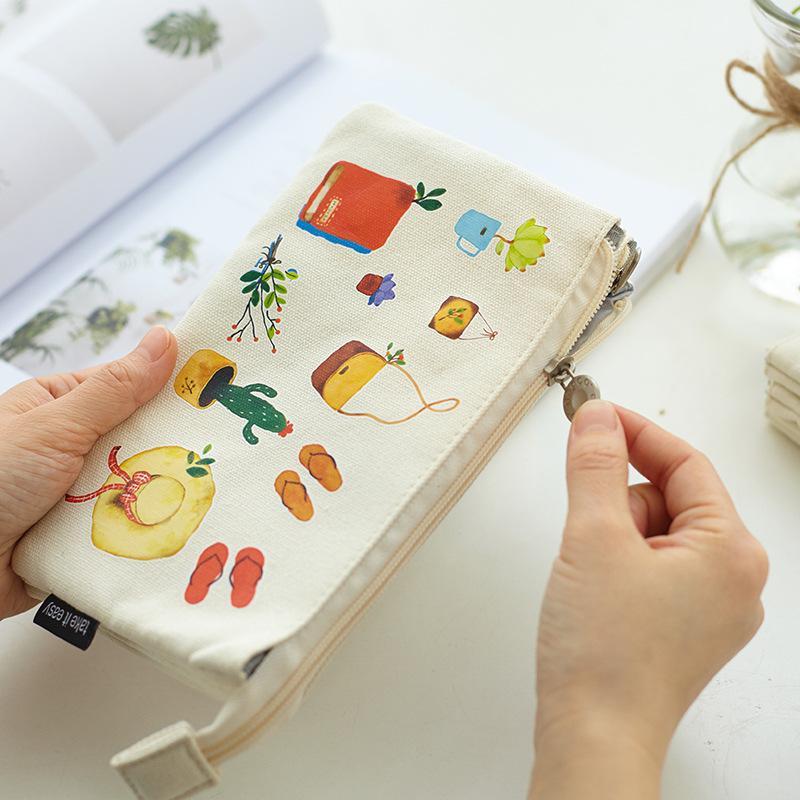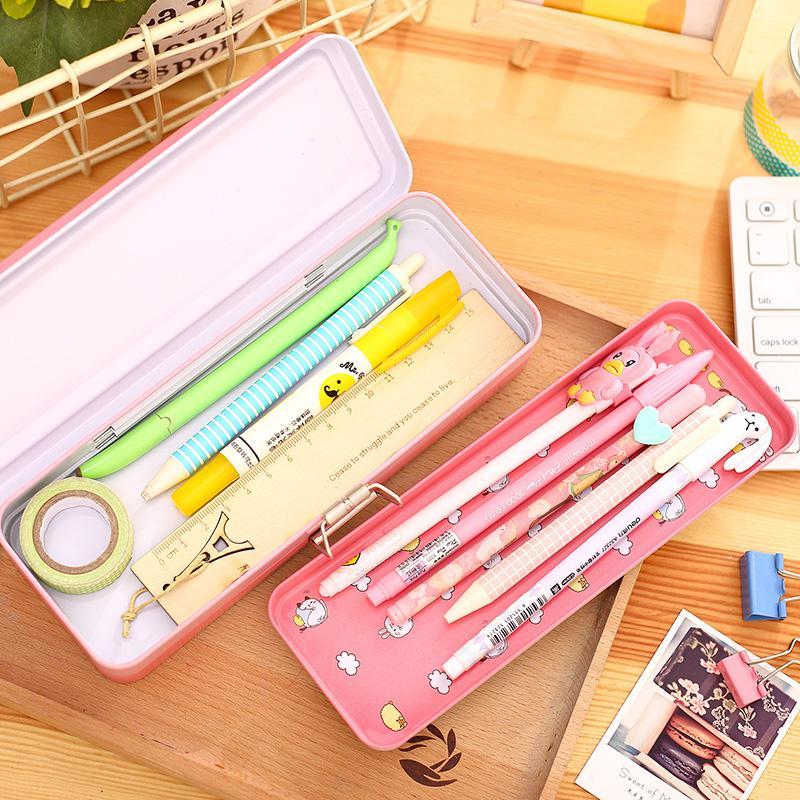The first image is the image on the left, the second image is the image on the right. Analyze the images presented: Is the assertion "At least one of the pencil cases has a brown cartoon bear on it." valid? Answer yes or no. No. The first image is the image on the left, the second image is the image on the right. Considering the images on both sides, is "At least one pencil case has a brown bear on it." valid? Answer yes or no. No. 